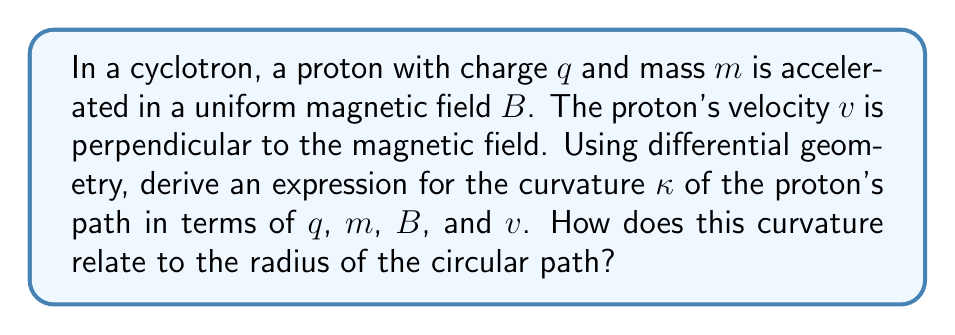Can you answer this question? Let's approach this step-by-step using differential geometry:

1) In a uniform magnetic field, the proton experiences a force perpendicular to its velocity, resulting in circular motion. The position vector $\mathbf{r}(t)$ of the proton can be described as:

   $$\mathbf{r}(t) = (R\cos(\omega t), R\sin(\omega t), 0)$$

   where $R$ is the radius of the circular path and $\omega$ is the angular velocity.

2) The velocity vector $\mathbf{v}(t)$ is the first derivative of $\mathbf{r}(t)$:

   $$\mathbf{v}(t) = \frac{d\mathbf{r}}{dt} = (-R\omega\sin(\omega t), R\omega\cos(\omega t), 0)$$

3) The acceleration vector $\mathbf{a}(t)$ is the second derivative of $\mathbf{r}(t)$:

   $$\mathbf{a}(t) = \frac{d^2\mathbf{r}}{dt^2} = (-R\omega^2\cos(\omega t), -R\omega^2\sin(\omega t), 0)$$

4) The curvature $\kappa$ is defined as:

   $$\kappa = \frac{|\mathbf{v} \times \mathbf{a}|}{|\mathbf{v}|^3}$$

5) Calculating $|\mathbf{v} \times \mathbf{a}|$:
   
   $$|\mathbf{v} \times \mathbf{a}| = R^2\omega^3$$

6) Calculating $|\mathbf{v}|$:

   $$|\mathbf{v}| = R\omega$$

7) Substituting into the curvature formula:

   $$\kappa = \frac{R^2\omega^3}{(R\omega)^3} = \frac{1}{R}$$

8) Now, we need to relate this to the physical parameters. In a cyclotron, the magnetic force provides the centripetal force:

   $$qvB = \frac{mv^2}{R}$$

9) Solving for $R$:

   $$R = \frac{mv}{qB}$$

10) Therefore, the curvature can be expressed as:

    $$\kappa = \frac{1}{R} = \frac{qB}{mv}$$

This expression relates the curvature to the charge $q$, mass $m$, magnetic field strength $B$, and velocity $v$ of the proton.

The curvature $\kappa$ is the reciprocal of the radius $R$ of the circular path.
Answer: $\kappa = \frac{qB}{mv}$, inverse of path radius 